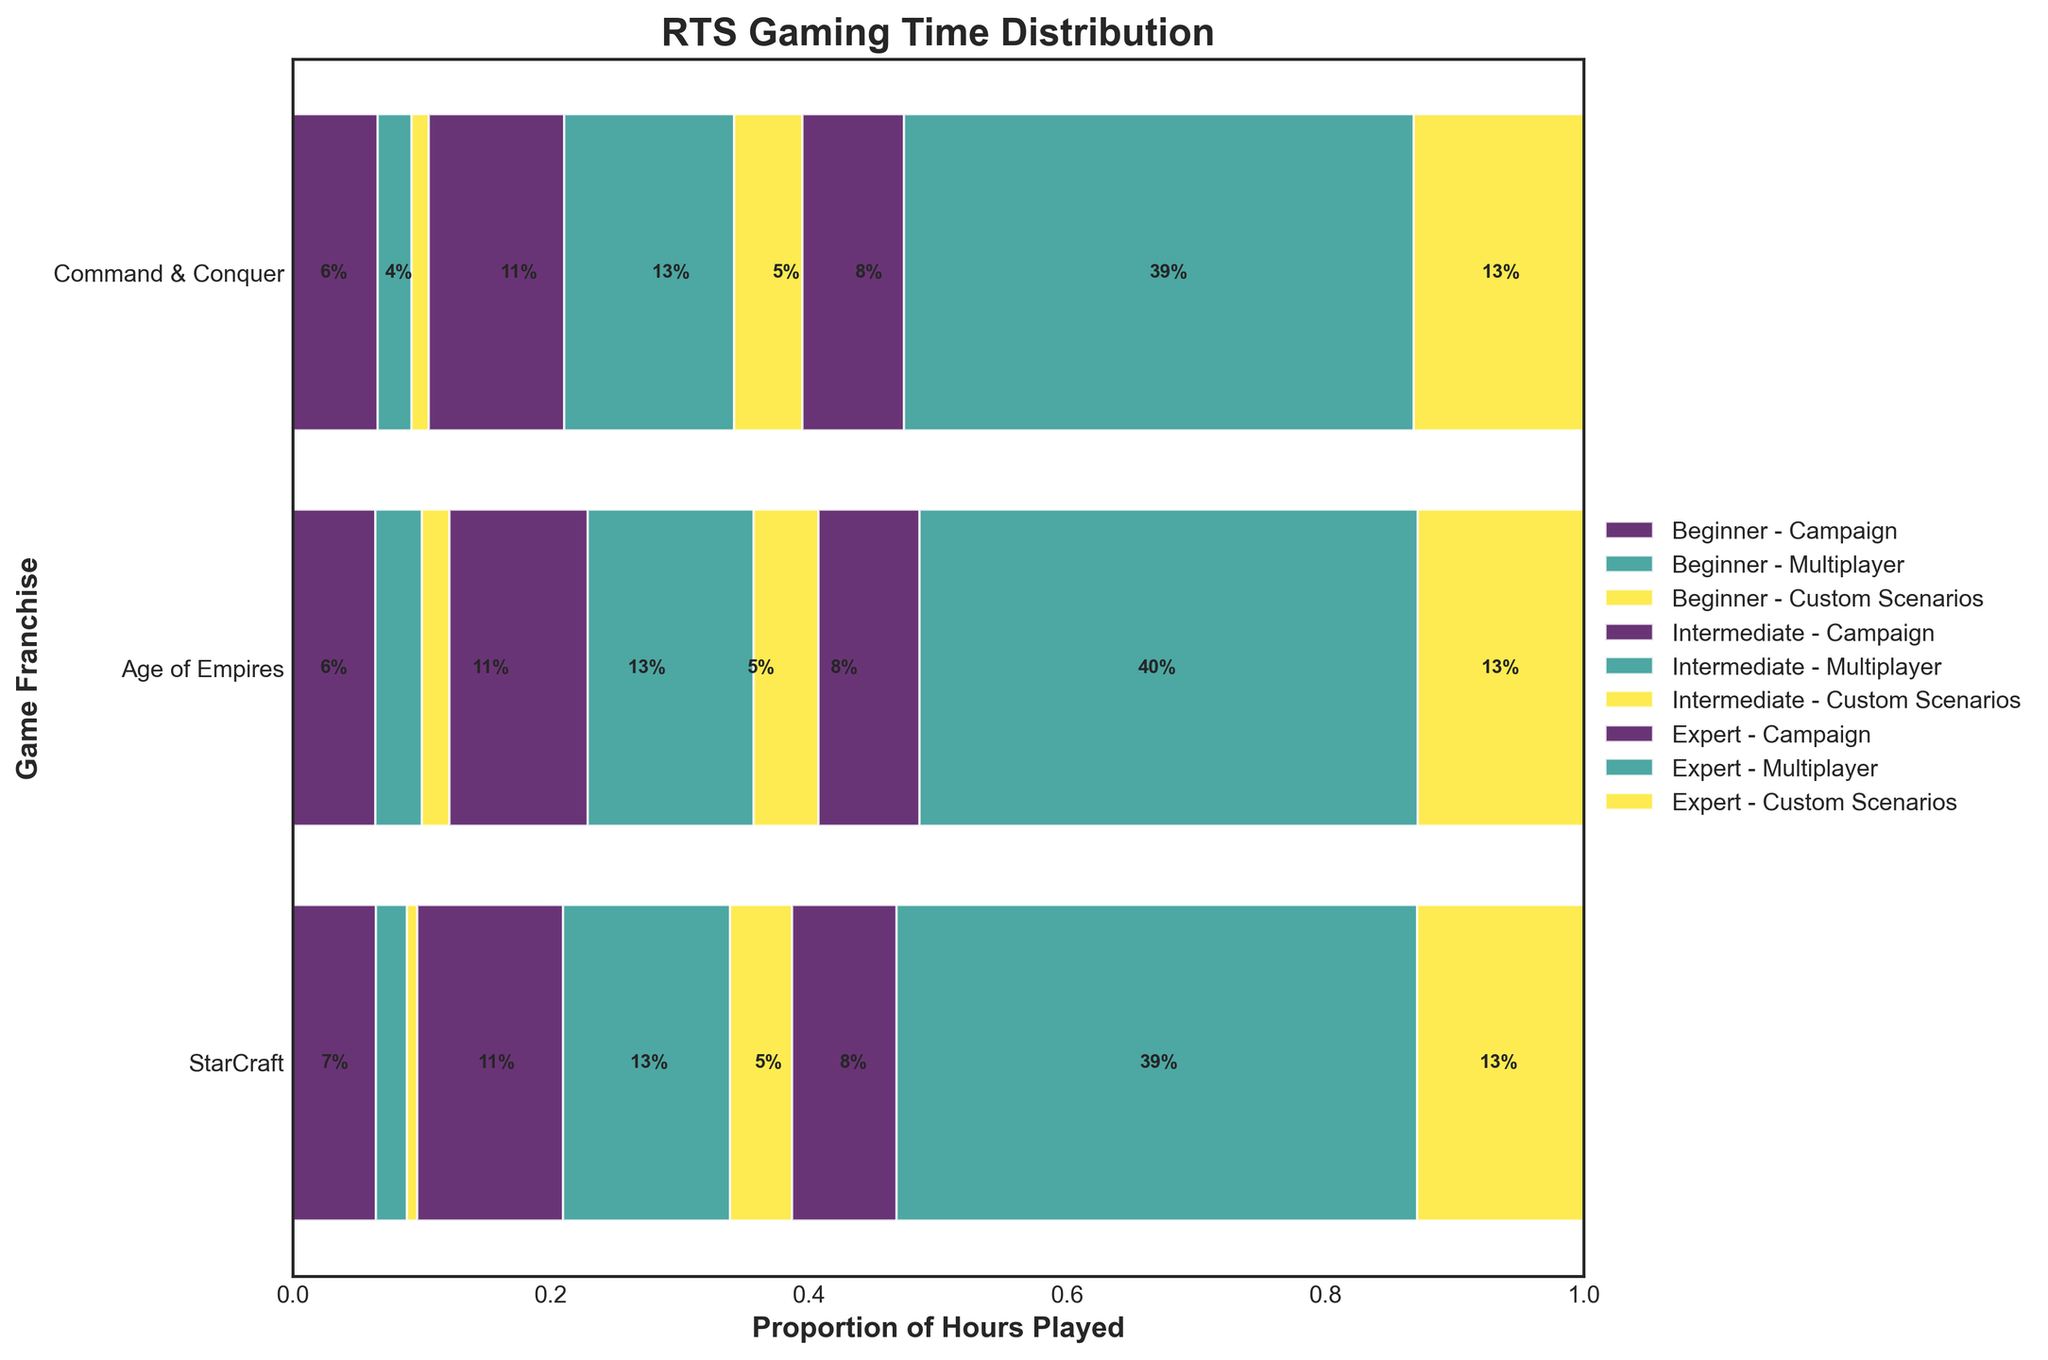How many game franchises are displayed in the figure? The figure has separate bars for each game franchise. By counting these, we see there are three game franchises visible.
Answer: Three What is the title of the plot? The title of the plot is displayed at the top center. It reads "RTS Gaming Time Distribution".
Answer: RTS Gaming Time Distribution Which game mode do experts spend the most time on in Command & Conquer? Look at the segment for Command & Conquer in the expert category. The widest segment represents the mode where the most time is spent.
Answer: Multiplayer Which player experience level in StarCraft has the highest proportion of time spent on Custom Scenarios? In the StarCraft section, compare the Custom Scenarios segments for all experience levels. The expert segment has the widest Custom Scenarios proportion.
Answer: Expert In Age of Empires, do beginners spend more time on Multiplayer or Custom Scenarios? Look at the Age of Empires beginner segments for Multiplayer and Custom Scenarios. The Multiplayer segment is larger.
Answer: Multiplayer What is the likely approximate proportion of time spent on Campaigns by intermediate players across all franchises? For each franchise's intermediate bar, estimate the proportion represented by the Campaign segment (width of the Campaign segment compared to the total width of the bar). StarCraft: 40%, Age of Empires: 35%, Command & Conquer: 30%. Calculate the average: (40% + 35% + 30%) / 3 = 35%.
Answer: 35% Which game franchise has the smallest proportion of hours played in Custom Scenarios by experts? Look at the Custom Scenarios segments in the expert bars for all franchises. Age of Empires has the smallest Custom Scenarios segment.
Answer: Age of Empires For StarCraft, how does the proportion of time spent on the Campaign mode by beginners compare to that by intermediates? Look at the Campaign segments for beginners and intermediates in StarCraft. The beginner segment is smaller than the intermediate segment.
Answer: Less Do experts in Command & Conquer spend more time on Multiplayer mode compared to experts in StarCraft? Compare the Multiplayer segments of the expert bars for Command & Conquer and StarCraft. Command & Conquer experts have a larger segment.
Answer: Yes 